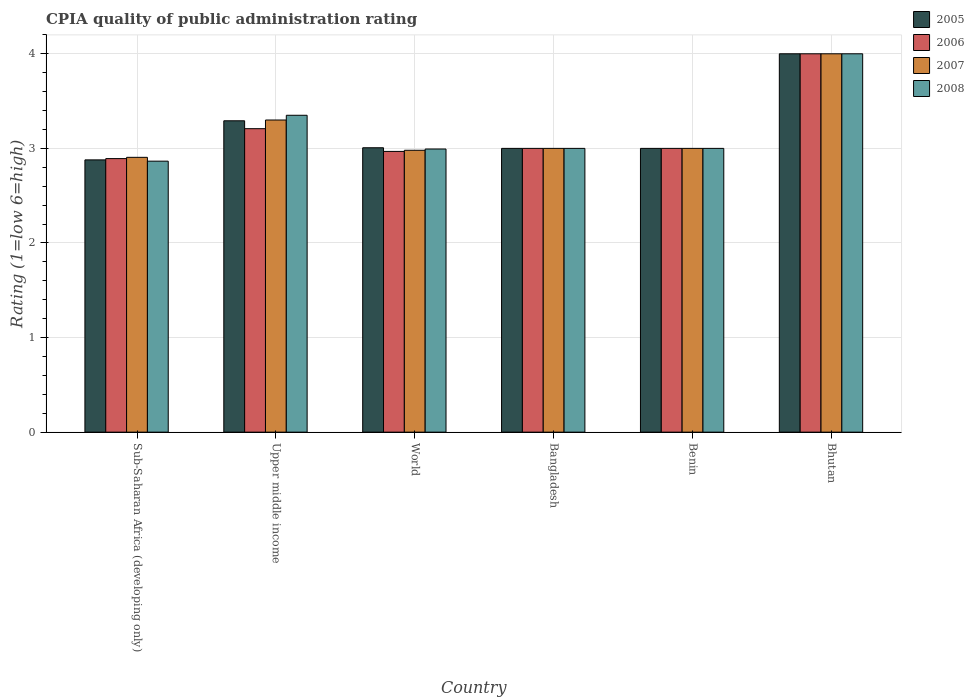How many groups of bars are there?
Give a very brief answer. 6. How many bars are there on the 6th tick from the right?
Give a very brief answer. 4. What is the label of the 5th group of bars from the left?
Your answer should be very brief. Benin. Across all countries, what is the minimum CPIA rating in 2006?
Ensure brevity in your answer.  2.89. In which country was the CPIA rating in 2005 maximum?
Make the answer very short. Bhutan. In which country was the CPIA rating in 2005 minimum?
Provide a succinct answer. Sub-Saharan Africa (developing only). What is the total CPIA rating in 2005 in the graph?
Your answer should be very brief. 19.18. What is the difference between the CPIA rating in 2007 in Bangladesh and that in World?
Provide a short and direct response. 0.02. What is the difference between the CPIA rating in 2006 in Benin and the CPIA rating in 2005 in World?
Make the answer very short. -0.01. What is the average CPIA rating in 2005 per country?
Provide a short and direct response. 3.2. What is the difference between the CPIA rating of/in 2006 and CPIA rating of/in 2007 in Benin?
Your answer should be very brief. 0. What is the ratio of the CPIA rating in 2007 in Bhutan to that in World?
Provide a succinct answer. 1.34. Is the CPIA rating in 2007 in Sub-Saharan Africa (developing only) less than that in World?
Offer a terse response. Yes. Is the difference between the CPIA rating in 2006 in Upper middle income and World greater than the difference between the CPIA rating in 2007 in Upper middle income and World?
Offer a terse response. No. What is the difference between the highest and the second highest CPIA rating in 2006?
Your response must be concise. -0.21. What is the difference between the highest and the lowest CPIA rating in 2008?
Provide a short and direct response. 1.14. In how many countries, is the CPIA rating in 2005 greater than the average CPIA rating in 2005 taken over all countries?
Provide a succinct answer. 2. Is the sum of the CPIA rating in 2006 in Benin and Sub-Saharan Africa (developing only) greater than the maximum CPIA rating in 2008 across all countries?
Give a very brief answer. Yes. What does the 3rd bar from the left in Benin represents?
Provide a succinct answer. 2007. Is it the case that in every country, the sum of the CPIA rating in 2007 and CPIA rating in 2008 is greater than the CPIA rating in 2005?
Your answer should be compact. Yes. How many countries are there in the graph?
Give a very brief answer. 6. Does the graph contain grids?
Make the answer very short. Yes. How are the legend labels stacked?
Your response must be concise. Vertical. What is the title of the graph?
Give a very brief answer. CPIA quality of public administration rating. What is the label or title of the X-axis?
Your answer should be very brief. Country. What is the Rating (1=low 6=high) of 2005 in Sub-Saharan Africa (developing only)?
Keep it short and to the point. 2.88. What is the Rating (1=low 6=high) of 2006 in Sub-Saharan Africa (developing only)?
Make the answer very short. 2.89. What is the Rating (1=low 6=high) in 2007 in Sub-Saharan Africa (developing only)?
Give a very brief answer. 2.91. What is the Rating (1=low 6=high) of 2008 in Sub-Saharan Africa (developing only)?
Your response must be concise. 2.86. What is the Rating (1=low 6=high) in 2005 in Upper middle income?
Your answer should be very brief. 3.29. What is the Rating (1=low 6=high) of 2006 in Upper middle income?
Your answer should be very brief. 3.21. What is the Rating (1=low 6=high) in 2008 in Upper middle income?
Offer a very short reply. 3.35. What is the Rating (1=low 6=high) in 2005 in World?
Ensure brevity in your answer.  3.01. What is the Rating (1=low 6=high) of 2006 in World?
Your response must be concise. 2.97. What is the Rating (1=low 6=high) of 2007 in World?
Your answer should be compact. 2.98. What is the Rating (1=low 6=high) in 2008 in World?
Your answer should be compact. 2.99. What is the Rating (1=low 6=high) in 2006 in Bangladesh?
Provide a succinct answer. 3. What is the Rating (1=low 6=high) of 2008 in Bangladesh?
Keep it short and to the point. 3. What is the Rating (1=low 6=high) of 2005 in Benin?
Ensure brevity in your answer.  3. What is the Rating (1=low 6=high) of 2008 in Benin?
Provide a short and direct response. 3. What is the Rating (1=low 6=high) of 2006 in Bhutan?
Keep it short and to the point. 4. What is the Rating (1=low 6=high) of 2008 in Bhutan?
Provide a succinct answer. 4. Across all countries, what is the maximum Rating (1=low 6=high) in 2006?
Give a very brief answer. 4. Across all countries, what is the maximum Rating (1=low 6=high) in 2007?
Give a very brief answer. 4. Across all countries, what is the minimum Rating (1=low 6=high) of 2005?
Keep it short and to the point. 2.88. Across all countries, what is the minimum Rating (1=low 6=high) of 2006?
Your answer should be compact. 2.89. Across all countries, what is the minimum Rating (1=low 6=high) of 2007?
Your response must be concise. 2.91. Across all countries, what is the minimum Rating (1=low 6=high) of 2008?
Your answer should be very brief. 2.86. What is the total Rating (1=low 6=high) in 2005 in the graph?
Your response must be concise. 19.18. What is the total Rating (1=low 6=high) of 2006 in the graph?
Keep it short and to the point. 19.07. What is the total Rating (1=low 6=high) of 2007 in the graph?
Keep it short and to the point. 19.19. What is the total Rating (1=low 6=high) in 2008 in the graph?
Offer a terse response. 19.21. What is the difference between the Rating (1=low 6=high) in 2005 in Sub-Saharan Africa (developing only) and that in Upper middle income?
Offer a terse response. -0.41. What is the difference between the Rating (1=low 6=high) of 2006 in Sub-Saharan Africa (developing only) and that in Upper middle income?
Provide a succinct answer. -0.32. What is the difference between the Rating (1=low 6=high) in 2007 in Sub-Saharan Africa (developing only) and that in Upper middle income?
Offer a very short reply. -0.39. What is the difference between the Rating (1=low 6=high) of 2008 in Sub-Saharan Africa (developing only) and that in Upper middle income?
Make the answer very short. -0.49. What is the difference between the Rating (1=low 6=high) of 2005 in Sub-Saharan Africa (developing only) and that in World?
Provide a short and direct response. -0.13. What is the difference between the Rating (1=low 6=high) in 2006 in Sub-Saharan Africa (developing only) and that in World?
Provide a succinct answer. -0.08. What is the difference between the Rating (1=low 6=high) in 2007 in Sub-Saharan Africa (developing only) and that in World?
Your answer should be very brief. -0.07. What is the difference between the Rating (1=low 6=high) of 2008 in Sub-Saharan Africa (developing only) and that in World?
Offer a very short reply. -0.13. What is the difference between the Rating (1=low 6=high) in 2005 in Sub-Saharan Africa (developing only) and that in Bangladesh?
Your answer should be compact. -0.12. What is the difference between the Rating (1=low 6=high) in 2006 in Sub-Saharan Africa (developing only) and that in Bangladesh?
Keep it short and to the point. -0.11. What is the difference between the Rating (1=low 6=high) of 2007 in Sub-Saharan Africa (developing only) and that in Bangladesh?
Your answer should be compact. -0.09. What is the difference between the Rating (1=low 6=high) of 2008 in Sub-Saharan Africa (developing only) and that in Bangladesh?
Give a very brief answer. -0.14. What is the difference between the Rating (1=low 6=high) in 2005 in Sub-Saharan Africa (developing only) and that in Benin?
Give a very brief answer. -0.12. What is the difference between the Rating (1=low 6=high) in 2006 in Sub-Saharan Africa (developing only) and that in Benin?
Provide a short and direct response. -0.11. What is the difference between the Rating (1=low 6=high) in 2007 in Sub-Saharan Africa (developing only) and that in Benin?
Make the answer very short. -0.09. What is the difference between the Rating (1=low 6=high) of 2008 in Sub-Saharan Africa (developing only) and that in Benin?
Offer a very short reply. -0.14. What is the difference between the Rating (1=low 6=high) in 2005 in Sub-Saharan Africa (developing only) and that in Bhutan?
Provide a short and direct response. -1.12. What is the difference between the Rating (1=low 6=high) of 2006 in Sub-Saharan Africa (developing only) and that in Bhutan?
Offer a very short reply. -1.11. What is the difference between the Rating (1=low 6=high) of 2007 in Sub-Saharan Africa (developing only) and that in Bhutan?
Ensure brevity in your answer.  -1.09. What is the difference between the Rating (1=low 6=high) of 2008 in Sub-Saharan Africa (developing only) and that in Bhutan?
Give a very brief answer. -1.14. What is the difference between the Rating (1=low 6=high) of 2005 in Upper middle income and that in World?
Offer a terse response. 0.29. What is the difference between the Rating (1=low 6=high) of 2006 in Upper middle income and that in World?
Your answer should be very brief. 0.24. What is the difference between the Rating (1=low 6=high) in 2007 in Upper middle income and that in World?
Keep it short and to the point. 0.32. What is the difference between the Rating (1=low 6=high) in 2008 in Upper middle income and that in World?
Keep it short and to the point. 0.36. What is the difference between the Rating (1=low 6=high) of 2005 in Upper middle income and that in Bangladesh?
Your answer should be very brief. 0.29. What is the difference between the Rating (1=low 6=high) in 2006 in Upper middle income and that in Bangladesh?
Your answer should be very brief. 0.21. What is the difference between the Rating (1=low 6=high) in 2007 in Upper middle income and that in Bangladesh?
Offer a very short reply. 0.3. What is the difference between the Rating (1=low 6=high) of 2008 in Upper middle income and that in Bangladesh?
Provide a succinct answer. 0.35. What is the difference between the Rating (1=low 6=high) in 2005 in Upper middle income and that in Benin?
Give a very brief answer. 0.29. What is the difference between the Rating (1=low 6=high) in 2006 in Upper middle income and that in Benin?
Ensure brevity in your answer.  0.21. What is the difference between the Rating (1=low 6=high) in 2007 in Upper middle income and that in Benin?
Ensure brevity in your answer.  0.3. What is the difference between the Rating (1=low 6=high) in 2005 in Upper middle income and that in Bhutan?
Ensure brevity in your answer.  -0.71. What is the difference between the Rating (1=low 6=high) of 2006 in Upper middle income and that in Bhutan?
Give a very brief answer. -0.79. What is the difference between the Rating (1=low 6=high) of 2008 in Upper middle income and that in Bhutan?
Provide a succinct answer. -0.65. What is the difference between the Rating (1=low 6=high) in 2005 in World and that in Bangladesh?
Keep it short and to the point. 0.01. What is the difference between the Rating (1=low 6=high) in 2006 in World and that in Bangladesh?
Your answer should be compact. -0.03. What is the difference between the Rating (1=low 6=high) in 2007 in World and that in Bangladesh?
Your answer should be very brief. -0.02. What is the difference between the Rating (1=low 6=high) in 2008 in World and that in Bangladesh?
Provide a short and direct response. -0.01. What is the difference between the Rating (1=low 6=high) of 2005 in World and that in Benin?
Give a very brief answer. 0.01. What is the difference between the Rating (1=low 6=high) of 2006 in World and that in Benin?
Offer a very short reply. -0.03. What is the difference between the Rating (1=low 6=high) of 2007 in World and that in Benin?
Keep it short and to the point. -0.02. What is the difference between the Rating (1=low 6=high) in 2008 in World and that in Benin?
Keep it short and to the point. -0.01. What is the difference between the Rating (1=low 6=high) of 2005 in World and that in Bhutan?
Give a very brief answer. -0.99. What is the difference between the Rating (1=low 6=high) of 2006 in World and that in Bhutan?
Your answer should be compact. -1.03. What is the difference between the Rating (1=low 6=high) of 2007 in World and that in Bhutan?
Ensure brevity in your answer.  -1.02. What is the difference between the Rating (1=low 6=high) in 2008 in World and that in Bhutan?
Give a very brief answer. -1.01. What is the difference between the Rating (1=low 6=high) in 2006 in Bangladesh and that in Benin?
Offer a terse response. 0. What is the difference between the Rating (1=low 6=high) of 2005 in Bangladesh and that in Bhutan?
Give a very brief answer. -1. What is the difference between the Rating (1=low 6=high) in 2007 in Bangladesh and that in Bhutan?
Keep it short and to the point. -1. What is the difference between the Rating (1=low 6=high) of 2008 in Bangladesh and that in Bhutan?
Provide a short and direct response. -1. What is the difference between the Rating (1=low 6=high) in 2005 in Benin and that in Bhutan?
Your response must be concise. -1. What is the difference between the Rating (1=low 6=high) in 2006 in Benin and that in Bhutan?
Your answer should be compact. -1. What is the difference between the Rating (1=low 6=high) of 2007 in Benin and that in Bhutan?
Your response must be concise. -1. What is the difference between the Rating (1=low 6=high) in 2005 in Sub-Saharan Africa (developing only) and the Rating (1=low 6=high) in 2006 in Upper middle income?
Offer a very short reply. -0.33. What is the difference between the Rating (1=low 6=high) of 2005 in Sub-Saharan Africa (developing only) and the Rating (1=low 6=high) of 2007 in Upper middle income?
Keep it short and to the point. -0.42. What is the difference between the Rating (1=low 6=high) of 2005 in Sub-Saharan Africa (developing only) and the Rating (1=low 6=high) of 2008 in Upper middle income?
Provide a succinct answer. -0.47. What is the difference between the Rating (1=low 6=high) in 2006 in Sub-Saharan Africa (developing only) and the Rating (1=low 6=high) in 2007 in Upper middle income?
Your answer should be compact. -0.41. What is the difference between the Rating (1=low 6=high) of 2006 in Sub-Saharan Africa (developing only) and the Rating (1=low 6=high) of 2008 in Upper middle income?
Your response must be concise. -0.46. What is the difference between the Rating (1=low 6=high) of 2007 in Sub-Saharan Africa (developing only) and the Rating (1=low 6=high) of 2008 in Upper middle income?
Offer a terse response. -0.44. What is the difference between the Rating (1=low 6=high) in 2005 in Sub-Saharan Africa (developing only) and the Rating (1=low 6=high) in 2006 in World?
Your answer should be compact. -0.09. What is the difference between the Rating (1=low 6=high) in 2005 in Sub-Saharan Africa (developing only) and the Rating (1=low 6=high) in 2007 in World?
Keep it short and to the point. -0.1. What is the difference between the Rating (1=low 6=high) of 2005 in Sub-Saharan Africa (developing only) and the Rating (1=low 6=high) of 2008 in World?
Offer a very short reply. -0.12. What is the difference between the Rating (1=low 6=high) in 2006 in Sub-Saharan Africa (developing only) and the Rating (1=low 6=high) in 2007 in World?
Keep it short and to the point. -0.09. What is the difference between the Rating (1=low 6=high) of 2006 in Sub-Saharan Africa (developing only) and the Rating (1=low 6=high) of 2008 in World?
Provide a short and direct response. -0.1. What is the difference between the Rating (1=low 6=high) of 2007 in Sub-Saharan Africa (developing only) and the Rating (1=low 6=high) of 2008 in World?
Offer a terse response. -0.09. What is the difference between the Rating (1=low 6=high) of 2005 in Sub-Saharan Africa (developing only) and the Rating (1=low 6=high) of 2006 in Bangladesh?
Offer a terse response. -0.12. What is the difference between the Rating (1=low 6=high) in 2005 in Sub-Saharan Africa (developing only) and the Rating (1=low 6=high) in 2007 in Bangladesh?
Your answer should be compact. -0.12. What is the difference between the Rating (1=low 6=high) in 2005 in Sub-Saharan Africa (developing only) and the Rating (1=low 6=high) in 2008 in Bangladesh?
Make the answer very short. -0.12. What is the difference between the Rating (1=low 6=high) of 2006 in Sub-Saharan Africa (developing only) and the Rating (1=low 6=high) of 2007 in Bangladesh?
Give a very brief answer. -0.11. What is the difference between the Rating (1=low 6=high) in 2006 in Sub-Saharan Africa (developing only) and the Rating (1=low 6=high) in 2008 in Bangladesh?
Keep it short and to the point. -0.11. What is the difference between the Rating (1=low 6=high) in 2007 in Sub-Saharan Africa (developing only) and the Rating (1=low 6=high) in 2008 in Bangladesh?
Your response must be concise. -0.09. What is the difference between the Rating (1=low 6=high) of 2005 in Sub-Saharan Africa (developing only) and the Rating (1=low 6=high) of 2006 in Benin?
Provide a succinct answer. -0.12. What is the difference between the Rating (1=low 6=high) in 2005 in Sub-Saharan Africa (developing only) and the Rating (1=low 6=high) in 2007 in Benin?
Your answer should be very brief. -0.12. What is the difference between the Rating (1=low 6=high) of 2005 in Sub-Saharan Africa (developing only) and the Rating (1=low 6=high) of 2008 in Benin?
Give a very brief answer. -0.12. What is the difference between the Rating (1=low 6=high) of 2006 in Sub-Saharan Africa (developing only) and the Rating (1=low 6=high) of 2007 in Benin?
Make the answer very short. -0.11. What is the difference between the Rating (1=low 6=high) of 2006 in Sub-Saharan Africa (developing only) and the Rating (1=low 6=high) of 2008 in Benin?
Make the answer very short. -0.11. What is the difference between the Rating (1=low 6=high) of 2007 in Sub-Saharan Africa (developing only) and the Rating (1=low 6=high) of 2008 in Benin?
Your answer should be very brief. -0.09. What is the difference between the Rating (1=low 6=high) in 2005 in Sub-Saharan Africa (developing only) and the Rating (1=low 6=high) in 2006 in Bhutan?
Ensure brevity in your answer.  -1.12. What is the difference between the Rating (1=low 6=high) in 2005 in Sub-Saharan Africa (developing only) and the Rating (1=low 6=high) in 2007 in Bhutan?
Your answer should be very brief. -1.12. What is the difference between the Rating (1=low 6=high) in 2005 in Sub-Saharan Africa (developing only) and the Rating (1=low 6=high) in 2008 in Bhutan?
Provide a succinct answer. -1.12. What is the difference between the Rating (1=low 6=high) of 2006 in Sub-Saharan Africa (developing only) and the Rating (1=low 6=high) of 2007 in Bhutan?
Ensure brevity in your answer.  -1.11. What is the difference between the Rating (1=low 6=high) of 2006 in Sub-Saharan Africa (developing only) and the Rating (1=low 6=high) of 2008 in Bhutan?
Ensure brevity in your answer.  -1.11. What is the difference between the Rating (1=low 6=high) in 2007 in Sub-Saharan Africa (developing only) and the Rating (1=low 6=high) in 2008 in Bhutan?
Provide a short and direct response. -1.09. What is the difference between the Rating (1=low 6=high) in 2005 in Upper middle income and the Rating (1=low 6=high) in 2006 in World?
Provide a succinct answer. 0.32. What is the difference between the Rating (1=low 6=high) of 2005 in Upper middle income and the Rating (1=low 6=high) of 2007 in World?
Ensure brevity in your answer.  0.31. What is the difference between the Rating (1=low 6=high) in 2005 in Upper middle income and the Rating (1=low 6=high) in 2008 in World?
Provide a short and direct response. 0.3. What is the difference between the Rating (1=low 6=high) of 2006 in Upper middle income and the Rating (1=low 6=high) of 2007 in World?
Provide a short and direct response. 0.23. What is the difference between the Rating (1=low 6=high) of 2006 in Upper middle income and the Rating (1=low 6=high) of 2008 in World?
Ensure brevity in your answer.  0.21. What is the difference between the Rating (1=low 6=high) of 2007 in Upper middle income and the Rating (1=low 6=high) of 2008 in World?
Provide a succinct answer. 0.31. What is the difference between the Rating (1=low 6=high) in 2005 in Upper middle income and the Rating (1=low 6=high) in 2006 in Bangladesh?
Provide a succinct answer. 0.29. What is the difference between the Rating (1=low 6=high) of 2005 in Upper middle income and the Rating (1=low 6=high) of 2007 in Bangladesh?
Ensure brevity in your answer.  0.29. What is the difference between the Rating (1=low 6=high) of 2005 in Upper middle income and the Rating (1=low 6=high) of 2008 in Bangladesh?
Provide a short and direct response. 0.29. What is the difference between the Rating (1=low 6=high) in 2006 in Upper middle income and the Rating (1=low 6=high) in 2007 in Bangladesh?
Your response must be concise. 0.21. What is the difference between the Rating (1=low 6=high) of 2006 in Upper middle income and the Rating (1=low 6=high) of 2008 in Bangladesh?
Offer a very short reply. 0.21. What is the difference between the Rating (1=low 6=high) of 2005 in Upper middle income and the Rating (1=low 6=high) of 2006 in Benin?
Your answer should be compact. 0.29. What is the difference between the Rating (1=low 6=high) of 2005 in Upper middle income and the Rating (1=low 6=high) of 2007 in Benin?
Offer a very short reply. 0.29. What is the difference between the Rating (1=low 6=high) of 2005 in Upper middle income and the Rating (1=low 6=high) of 2008 in Benin?
Keep it short and to the point. 0.29. What is the difference between the Rating (1=low 6=high) in 2006 in Upper middle income and the Rating (1=low 6=high) in 2007 in Benin?
Provide a succinct answer. 0.21. What is the difference between the Rating (1=low 6=high) of 2006 in Upper middle income and the Rating (1=low 6=high) of 2008 in Benin?
Offer a terse response. 0.21. What is the difference between the Rating (1=low 6=high) in 2007 in Upper middle income and the Rating (1=low 6=high) in 2008 in Benin?
Give a very brief answer. 0.3. What is the difference between the Rating (1=low 6=high) in 2005 in Upper middle income and the Rating (1=low 6=high) in 2006 in Bhutan?
Offer a very short reply. -0.71. What is the difference between the Rating (1=low 6=high) in 2005 in Upper middle income and the Rating (1=low 6=high) in 2007 in Bhutan?
Provide a short and direct response. -0.71. What is the difference between the Rating (1=low 6=high) in 2005 in Upper middle income and the Rating (1=low 6=high) in 2008 in Bhutan?
Make the answer very short. -0.71. What is the difference between the Rating (1=low 6=high) in 2006 in Upper middle income and the Rating (1=low 6=high) in 2007 in Bhutan?
Your answer should be compact. -0.79. What is the difference between the Rating (1=low 6=high) in 2006 in Upper middle income and the Rating (1=low 6=high) in 2008 in Bhutan?
Your response must be concise. -0.79. What is the difference between the Rating (1=low 6=high) of 2007 in Upper middle income and the Rating (1=low 6=high) of 2008 in Bhutan?
Give a very brief answer. -0.7. What is the difference between the Rating (1=low 6=high) of 2005 in World and the Rating (1=low 6=high) of 2006 in Bangladesh?
Your answer should be very brief. 0.01. What is the difference between the Rating (1=low 6=high) of 2005 in World and the Rating (1=low 6=high) of 2007 in Bangladesh?
Offer a very short reply. 0.01. What is the difference between the Rating (1=low 6=high) in 2005 in World and the Rating (1=low 6=high) in 2008 in Bangladesh?
Keep it short and to the point. 0.01. What is the difference between the Rating (1=low 6=high) of 2006 in World and the Rating (1=low 6=high) of 2007 in Bangladesh?
Offer a very short reply. -0.03. What is the difference between the Rating (1=low 6=high) of 2006 in World and the Rating (1=low 6=high) of 2008 in Bangladesh?
Give a very brief answer. -0.03. What is the difference between the Rating (1=low 6=high) in 2007 in World and the Rating (1=low 6=high) in 2008 in Bangladesh?
Your answer should be very brief. -0.02. What is the difference between the Rating (1=low 6=high) of 2005 in World and the Rating (1=low 6=high) of 2006 in Benin?
Make the answer very short. 0.01. What is the difference between the Rating (1=low 6=high) of 2005 in World and the Rating (1=low 6=high) of 2007 in Benin?
Give a very brief answer. 0.01. What is the difference between the Rating (1=low 6=high) in 2005 in World and the Rating (1=low 6=high) in 2008 in Benin?
Provide a short and direct response. 0.01. What is the difference between the Rating (1=low 6=high) in 2006 in World and the Rating (1=low 6=high) in 2007 in Benin?
Your answer should be compact. -0.03. What is the difference between the Rating (1=low 6=high) in 2006 in World and the Rating (1=low 6=high) in 2008 in Benin?
Offer a terse response. -0.03. What is the difference between the Rating (1=low 6=high) of 2007 in World and the Rating (1=low 6=high) of 2008 in Benin?
Give a very brief answer. -0.02. What is the difference between the Rating (1=low 6=high) in 2005 in World and the Rating (1=low 6=high) in 2006 in Bhutan?
Give a very brief answer. -0.99. What is the difference between the Rating (1=low 6=high) in 2005 in World and the Rating (1=low 6=high) in 2007 in Bhutan?
Offer a very short reply. -0.99. What is the difference between the Rating (1=low 6=high) of 2005 in World and the Rating (1=low 6=high) of 2008 in Bhutan?
Make the answer very short. -0.99. What is the difference between the Rating (1=low 6=high) of 2006 in World and the Rating (1=low 6=high) of 2007 in Bhutan?
Make the answer very short. -1.03. What is the difference between the Rating (1=low 6=high) of 2006 in World and the Rating (1=low 6=high) of 2008 in Bhutan?
Offer a terse response. -1.03. What is the difference between the Rating (1=low 6=high) of 2007 in World and the Rating (1=low 6=high) of 2008 in Bhutan?
Provide a succinct answer. -1.02. What is the difference between the Rating (1=low 6=high) in 2005 in Bangladesh and the Rating (1=low 6=high) in 2007 in Benin?
Keep it short and to the point. 0. What is the difference between the Rating (1=low 6=high) of 2005 in Bangladesh and the Rating (1=low 6=high) of 2008 in Benin?
Provide a short and direct response. 0. What is the difference between the Rating (1=low 6=high) in 2007 in Bangladesh and the Rating (1=low 6=high) in 2008 in Benin?
Give a very brief answer. 0. What is the difference between the Rating (1=low 6=high) of 2005 in Bangladesh and the Rating (1=low 6=high) of 2006 in Bhutan?
Give a very brief answer. -1. What is the difference between the Rating (1=low 6=high) of 2005 in Bangladesh and the Rating (1=low 6=high) of 2007 in Bhutan?
Provide a short and direct response. -1. What is the difference between the Rating (1=low 6=high) of 2005 in Bangladesh and the Rating (1=low 6=high) of 2008 in Bhutan?
Your answer should be very brief. -1. What is the difference between the Rating (1=low 6=high) of 2006 in Bangladesh and the Rating (1=low 6=high) of 2007 in Bhutan?
Your answer should be very brief. -1. What is the difference between the Rating (1=low 6=high) in 2005 in Benin and the Rating (1=low 6=high) in 2007 in Bhutan?
Keep it short and to the point. -1. What is the difference between the Rating (1=low 6=high) of 2005 in Benin and the Rating (1=low 6=high) of 2008 in Bhutan?
Your answer should be compact. -1. What is the difference between the Rating (1=low 6=high) of 2007 in Benin and the Rating (1=low 6=high) of 2008 in Bhutan?
Offer a very short reply. -1. What is the average Rating (1=low 6=high) of 2005 per country?
Provide a succinct answer. 3.2. What is the average Rating (1=low 6=high) of 2006 per country?
Offer a terse response. 3.18. What is the average Rating (1=low 6=high) in 2007 per country?
Offer a terse response. 3.2. What is the average Rating (1=low 6=high) in 2008 per country?
Ensure brevity in your answer.  3.2. What is the difference between the Rating (1=low 6=high) in 2005 and Rating (1=low 6=high) in 2006 in Sub-Saharan Africa (developing only)?
Your answer should be compact. -0.01. What is the difference between the Rating (1=low 6=high) in 2005 and Rating (1=low 6=high) in 2007 in Sub-Saharan Africa (developing only)?
Your answer should be very brief. -0.03. What is the difference between the Rating (1=low 6=high) in 2005 and Rating (1=low 6=high) in 2008 in Sub-Saharan Africa (developing only)?
Give a very brief answer. 0.01. What is the difference between the Rating (1=low 6=high) in 2006 and Rating (1=low 6=high) in 2007 in Sub-Saharan Africa (developing only)?
Make the answer very short. -0.01. What is the difference between the Rating (1=low 6=high) in 2006 and Rating (1=low 6=high) in 2008 in Sub-Saharan Africa (developing only)?
Keep it short and to the point. 0.03. What is the difference between the Rating (1=low 6=high) in 2007 and Rating (1=low 6=high) in 2008 in Sub-Saharan Africa (developing only)?
Offer a terse response. 0.04. What is the difference between the Rating (1=low 6=high) in 2005 and Rating (1=low 6=high) in 2006 in Upper middle income?
Provide a succinct answer. 0.08. What is the difference between the Rating (1=low 6=high) of 2005 and Rating (1=low 6=high) of 2007 in Upper middle income?
Offer a very short reply. -0.01. What is the difference between the Rating (1=low 6=high) of 2005 and Rating (1=low 6=high) of 2008 in Upper middle income?
Your answer should be very brief. -0.06. What is the difference between the Rating (1=low 6=high) in 2006 and Rating (1=low 6=high) in 2007 in Upper middle income?
Offer a very short reply. -0.09. What is the difference between the Rating (1=low 6=high) in 2006 and Rating (1=low 6=high) in 2008 in Upper middle income?
Your response must be concise. -0.14. What is the difference between the Rating (1=low 6=high) of 2007 and Rating (1=low 6=high) of 2008 in Upper middle income?
Your answer should be compact. -0.05. What is the difference between the Rating (1=low 6=high) in 2005 and Rating (1=low 6=high) in 2006 in World?
Offer a terse response. 0.04. What is the difference between the Rating (1=low 6=high) of 2005 and Rating (1=low 6=high) of 2007 in World?
Offer a terse response. 0.03. What is the difference between the Rating (1=low 6=high) in 2005 and Rating (1=low 6=high) in 2008 in World?
Provide a short and direct response. 0.01. What is the difference between the Rating (1=low 6=high) of 2006 and Rating (1=low 6=high) of 2007 in World?
Give a very brief answer. -0.01. What is the difference between the Rating (1=low 6=high) of 2006 and Rating (1=low 6=high) of 2008 in World?
Give a very brief answer. -0.03. What is the difference between the Rating (1=low 6=high) in 2007 and Rating (1=low 6=high) in 2008 in World?
Provide a succinct answer. -0.01. What is the difference between the Rating (1=low 6=high) of 2005 and Rating (1=low 6=high) of 2006 in Bangladesh?
Ensure brevity in your answer.  0. What is the difference between the Rating (1=low 6=high) of 2005 and Rating (1=low 6=high) of 2007 in Bangladesh?
Offer a very short reply. 0. What is the difference between the Rating (1=low 6=high) in 2007 and Rating (1=low 6=high) in 2008 in Bangladesh?
Provide a succinct answer. 0. What is the difference between the Rating (1=low 6=high) in 2005 and Rating (1=low 6=high) in 2006 in Benin?
Your answer should be very brief. 0. What is the difference between the Rating (1=low 6=high) in 2005 and Rating (1=low 6=high) in 2007 in Benin?
Give a very brief answer. 0. What is the difference between the Rating (1=low 6=high) of 2006 and Rating (1=low 6=high) of 2007 in Benin?
Your answer should be compact. 0. What is the difference between the Rating (1=low 6=high) of 2005 and Rating (1=low 6=high) of 2006 in Bhutan?
Offer a terse response. 0. What is the difference between the Rating (1=low 6=high) in 2005 and Rating (1=low 6=high) in 2007 in Bhutan?
Provide a short and direct response. 0. What is the difference between the Rating (1=low 6=high) in 2005 and Rating (1=low 6=high) in 2008 in Bhutan?
Give a very brief answer. 0. What is the difference between the Rating (1=low 6=high) in 2006 and Rating (1=low 6=high) in 2007 in Bhutan?
Your answer should be compact. 0. What is the difference between the Rating (1=low 6=high) in 2006 and Rating (1=low 6=high) in 2008 in Bhutan?
Your response must be concise. 0. What is the difference between the Rating (1=low 6=high) in 2007 and Rating (1=low 6=high) in 2008 in Bhutan?
Offer a terse response. 0. What is the ratio of the Rating (1=low 6=high) in 2005 in Sub-Saharan Africa (developing only) to that in Upper middle income?
Provide a succinct answer. 0.87. What is the ratio of the Rating (1=low 6=high) of 2006 in Sub-Saharan Africa (developing only) to that in Upper middle income?
Your answer should be very brief. 0.9. What is the ratio of the Rating (1=low 6=high) of 2007 in Sub-Saharan Africa (developing only) to that in Upper middle income?
Your answer should be compact. 0.88. What is the ratio of the Rating (1=low 6=high) of 2008 in Sub-Saharan Africa (developing only) to that in Upper middle income?
Ensure brevity in your answer.  0.86. What is the ratio of the Rating (1=low 6=high) of 2005 in Sub-Saharan Africa (developing only) to that in World?
Offer a terse response. 0.96. What is the ratio of the Rating (1=low 6=high) of 2006 in Sub-Saharan Africa (developing only) to that in World?
Keep it short and to the point. 0.97. What is the ratio of the Rating (1=low 6=high) in 2007 in Sub-Saharan Africa (developing only) to that in World?
Ensure brevity in your answer.  0.97. What is the ratio of the Rating (1=low 6=high) in 2008 in Sub-Saharan Africa (developing only) to that in World?
Offer a terse response. 0.96. What is the ratio of the Rating (1=low 6=high) of 2005 in Sub-Saharan Africa (developing only) to that in Bangladesh?
Your response must be concise. 0.96. What is the ratio of the Rating (1=low 6=high) of 2007 in Sub-Saharan Africa (developing only) to that in Bangladesh?
Your response must be concise. 0.97. What is the ratio of the Rating (1=low 6=high) of 2008 in Sub-Saharan Africa (developing only) to that in Bangladesh?
Make the answer very short. 0.95. What is the ratio of the Rating (1=low 6=high) in 2005 in Sub-Saharan Africa (developing only) to that in Benin?
Offer a very short reply. 0.96. What is the ratio of the Rating (1=low 6=high) in 2007 in Sub-Saharan Africa (developing only) to that in Benin?
Provide a short and direct response. 0.97. What is the ratio of the Rating (1=low 6=high) in 2008 in Sub-Saharan Africa (developing only) to that in Benin?
Keep it short and to the point. 0.95. What is the ratio of the Rating (1=low 6=high) of 2005 in Sub-Saharan Africa (developing only) to that in Bhutan?
Your answer should be compact. 0.72. What is the ratio of the Rating (1=low 6=high) in 2006 in Sub-Saharan Africa (developing only) to that in Bhutan?
Provide a short and direct response. 0.72. What is the ratio of the Rating (1=low 6=high) of 2007 in Sub-Saharan Africa (developing only) to that in Bhutan?
Your answer should be very brief. 0.73. What is the ratio of the Rating (1=low 6=high) in 2008 in Sub-Saharan Africa (developing only) to that in Bhutan?
Your response must be concise. 0.72. What is the ratio of the Rating (1=low 6=high) in 2005 in Upper middle income to that in World?
Your response must be concise. 1.09. What is the ratio of the Rating (1=low 6=high) in 2006 in Upper middle income to that in World?
Make the answer very short. 1.08. What is the ratio of the Rating (1=low 6=high) of 2007 in Upper middle income to that in World?
Your answer should be compact. 1.11. What is the ratio of the Rating (1=low 6=high) in 2008 in Upper middle income to that in World?
Your response must be concise. 1.12. What is the ratio of the Rating (1=low 6=high) in 2005 in Upper middle income to that in Bangladesh?
Give a very brief answer. 1.1. What is the ratio of the Rating (1=low 6=high) of 2006 in Upper middle income to that in Bangladesh?
Your response must be concise. 1.07. What is the ratio of the Rating (1=low 6=high) of 2007 in Upper middle income to that in Bangladesh?
Keep it short and to the point. 1.1. What is the ratio of the Rating (1=low 6=high) in 2008 in Upper middle income to that in Bangladesh?
Ensure brevity in your answer.  1.12. What is the ratio of the Rating (1=low 6=high) in 2005 in Upper middle income to that in Benin?
Make the answer very short. 1.1. What is the ratio of the Rating (1=low 6=high) in 2006 in Upper middle income to that in Benin?
Ensure brevity in your answer.  1.07. What is the ratio of the Rating (1=low 6=high) in 2008 in Upper middle income to that in Benin?
Offer a terse response. 1.12. What is the ratio of the Rating (1=low 6=high) of 2005 in Upper middle income to that in Bhutan?
Make the answer very short. 0.82. What is the ratio of the Rating (1=low 6=high) of 2006 in Upper middle income to that in Bhutan?
Offer a very short reply. 0.8. What is the ratio of the Rating (1=low 6=high) of 2007 in Upper middle income to that in Bhutan?
Ensure brevity in your answer.  0.82. What is the ratio of the Rating (1=low 6=high) of 2008 in Upper middle income to that in Bhutan?
Provide a short and direct response. 0.84. What is the ratio of the Rating (1=low 6=high) in 2005 in World to that in Bangladesh?
Provide a short and direct response. 1. What is the ratio of the Rating (1=low 6=high) in 2006 in World to that in Bangladesh?
Keep it short and to the point. 0.99. What is the ratio of the Rating (1=low 6=high) in 2008 in World to that in Bangladesh?
Offer a very short reply. 1. What is the ratio of the Rating (1=low 6=high) in 2005 in World to that in Benin?
Your answer should be very brief. 1. What is the ratio of the Rating (1=low 6=high) of 2006 in World to that in Benin?
Keep it short and to the point. 0.99. What is the ratio of the Rating (1=low 6=high) of 2008 in World to that in Benin?
Your answer should be very brief. 1. What is the ratio of the Rating (1=low 6=high) of 2005 in World to that in Bhutan?
Provide a succinct answer. 0.75. What is the ratio of the Rating (1=low 6=high) in 2006 in World to that in Bhutan?
Keep it short and to the point. 0.74. What is the ratio of the Rating (1=low 6=high) in 2007 in World to that in Bhutan?
Your response must be concise. 0.74. What is the ratio of the Rating (1=low 6=high) in 2008 in World to that in Bhutan?
Provide a succinct answer. 0.75. What is the ratio of the Rating (1=low 6=high) in 2005 in Bangladesh to that in Benin?
Offer a terse response. 1. What is the ratio of the Rating (1=low 6=high) of 2006 in Bangladesh to that in Benin?
Keep it short and to the point. 1. What is the ratio of the Rating (1=low 6=high) of 2007 in Bangladesh to that in Benin?
Your response must be concise. 1. What is the ratio of the Rating (1=low 6=high) of 2008 in Bangladesh to that in Benin?
Provide a succinct answer. 1. What is the ratio of the Rating (1=low 6=high) of 2007 in Bangladesh to that in Bhutan?
Keep it short and to the point. 0.75. What is the ratio of the Rating (1=low 6=high) in 2008 in Bangladesh to that in Bhutan?
Ensure brevity in your answer.  0.75. What is the difference between the highest and the second highest Rating (1=low 6=high) of 2005?
Make the answer very short. 0.71. What is the difference between the highest and the second highest Rating (1=low 6=high) in 2006?
Your response must be concise. 0.79. What is the difference between the highest and the second highest Rating (1=low 6=high) in 2007?
Make the answer very short. 0.7. What is the difference between the highest and the second highest Rating (1=low 6=high) of 2008?
Your answer should be very brief. 0.65. What is the difference between the highest and the lowest Rating (1=low 6=high) of 2005?
Provide a succinct answer. 1.12. What is the difference between the highest and the lowest Rating (1=low 6=high) of 2006?
Provide a succinct answer. 1.11. What is the difference between the highest and the lowest Rating (1=low 6=high) of 2007?
Provide a short and direct response. 1.09. What is the difference between the highest and the lowest Rating (1=low 6=high) in 2008?
Keep it short and to the point. 1.14. 